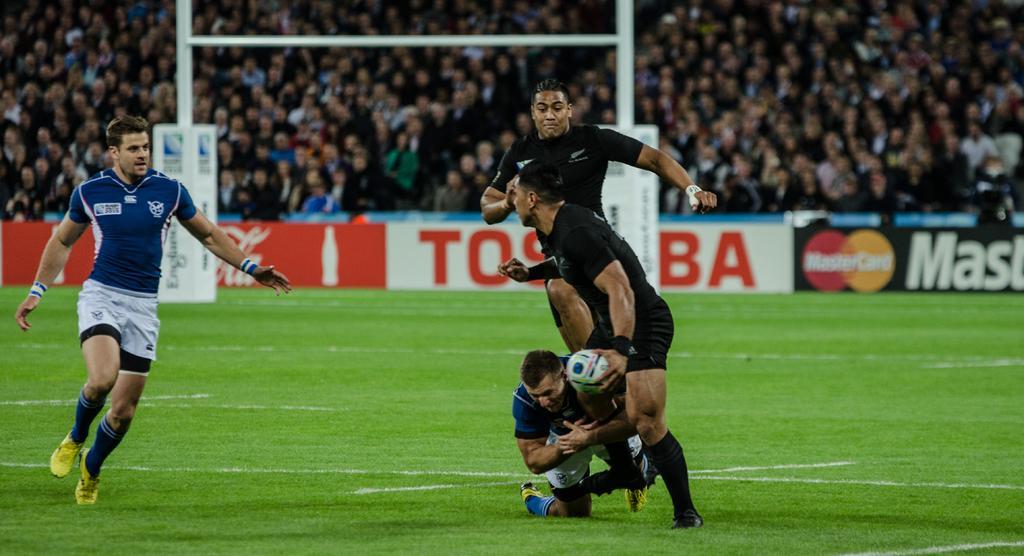Please provide a concise description of this image. Here we can see few men playing a rugby ball in a play ground. Behind to the hoarding we can see all the crowd. 